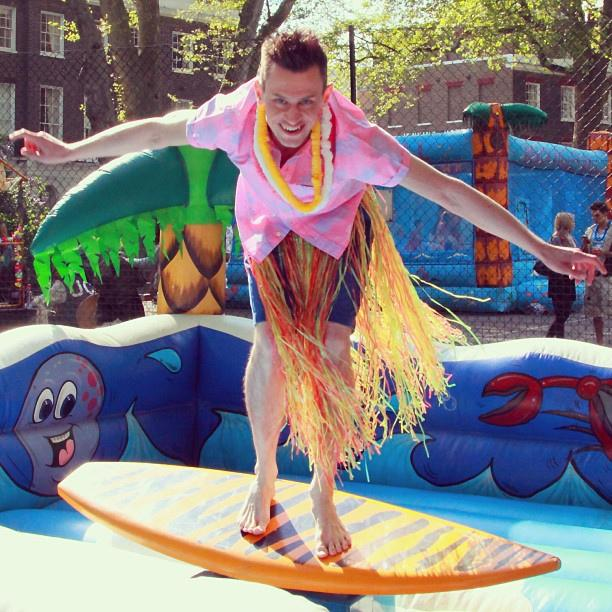What kind of animal is the cartoon face on the left? Please explain your reasoning. octopus. The animal is an octopus. 